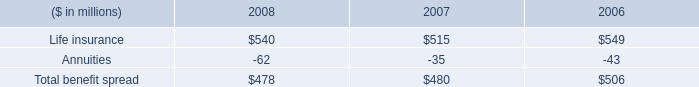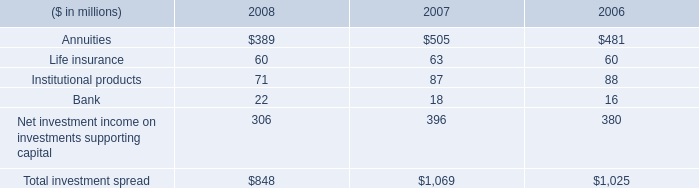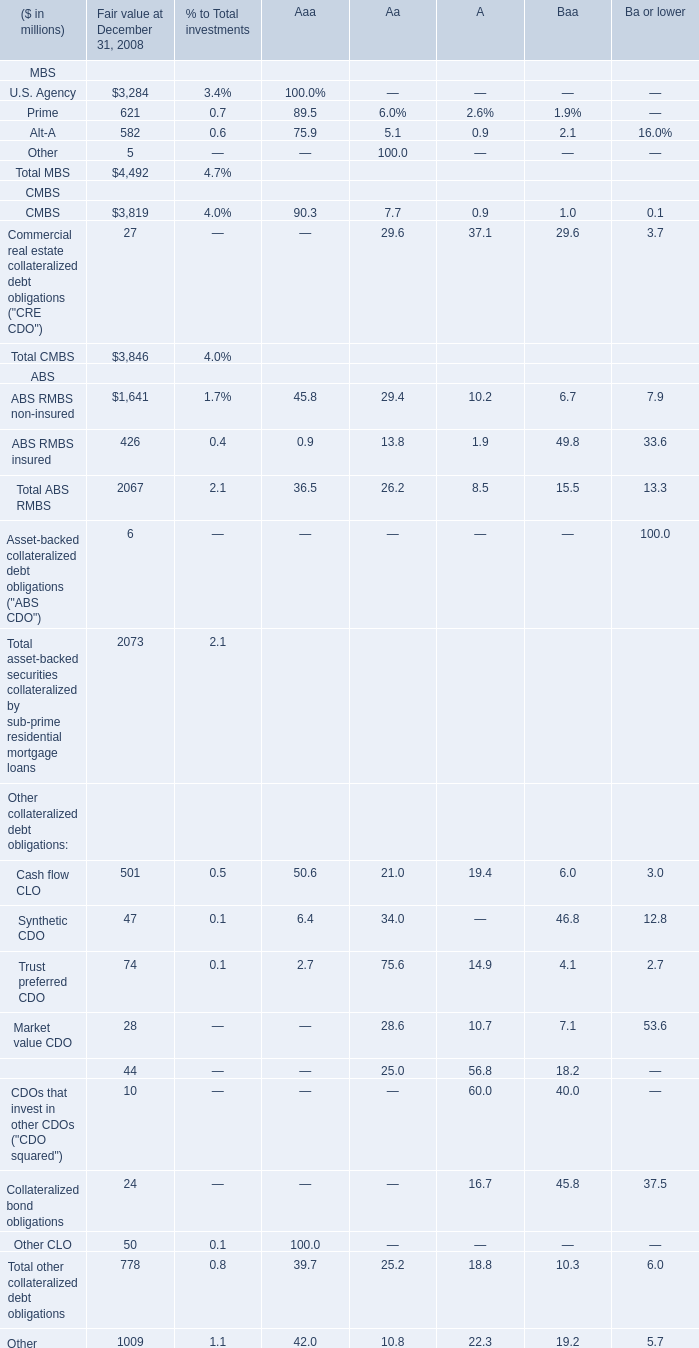what is the highest total amount of Cash flow CLO? (in million) 
Answer: 501. 